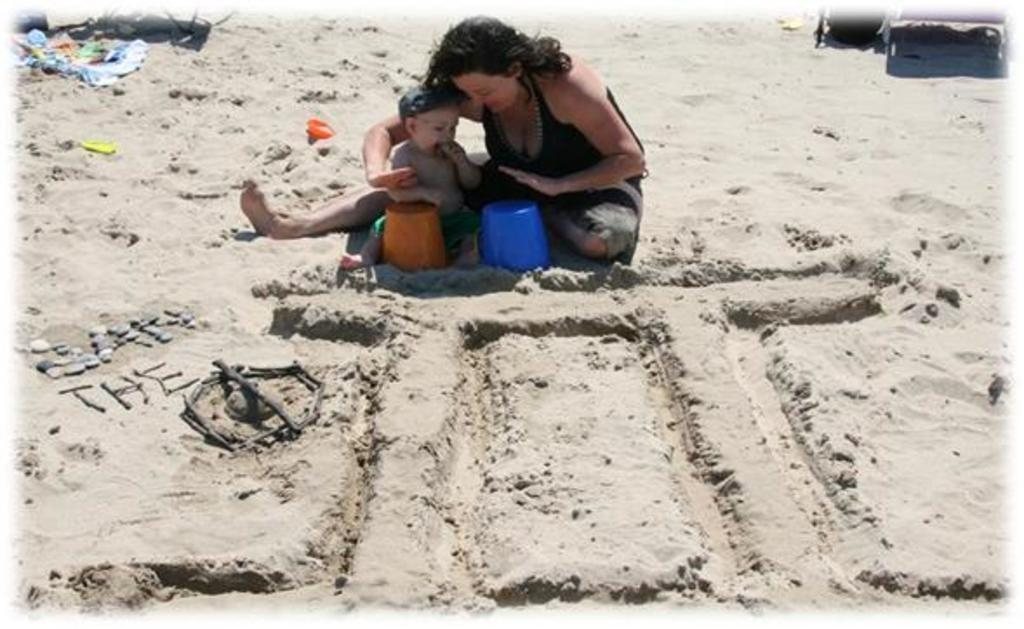Who is the main subject in the center of the image? There is a lady in the center of the image. What is the lady doing in the image? The lady and the baby are playing in the image. Where are they sitting? They are sitting on the sand. What else can be seen in the image? There are toys and clothes visible in the image. What type of belief is the lady expressing in the image? There is no indication of any beliefs being expressed in the image; it primarily shows the lady and the baby playing on the sand. 